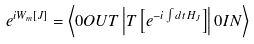<formula> <loc_0><loc_0><loc_500><loc_500>e ^ { i W _ { m } \left [ J \right ] } = \left \langle 0 O U T \left | T \left [ e ^ { - i \int d t \, H _ { J } } \right ] \right | 0 I N \right \rangle</formula> 